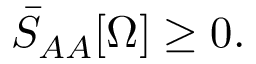<formula> <loc_0><loc_0><loc_500><loc_500>\bar { S } _ { A A } [ \Omega ] \geq 0 .</formula> 